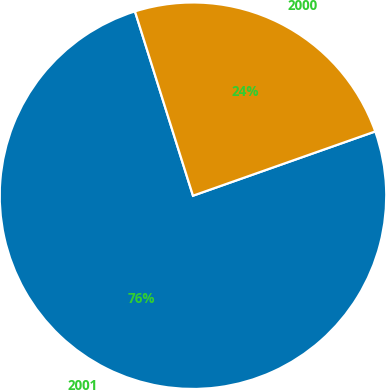Convert chart. <chart><loc_0><loc_0><loc_500><loc_500><pie_chart><fcel>2001<fcel>2000<nl><fcel>75.54%<fcel>24.46%<nl></chart> 